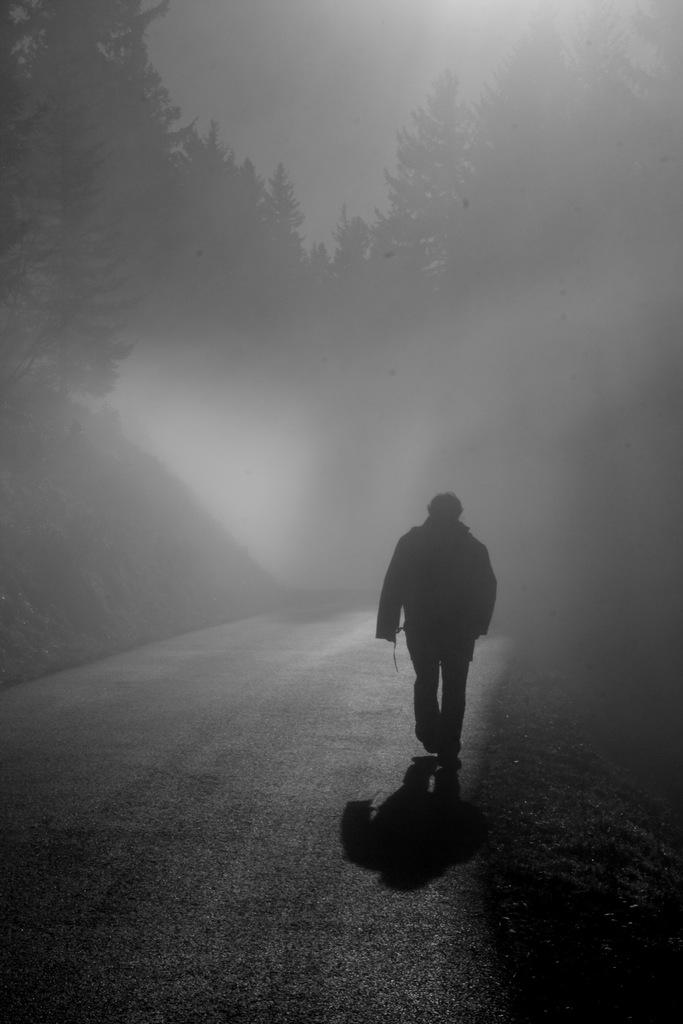What is the color scheme of the image? The image is black and white. What is the main subject of the image? There is a person walking on the road in the center of the image. What can be seen in the background of the image? The background of the image includes the sky, trees, and smoke. How many flowers can be seen on the road in the image? There are no flowers visible on the road in the image. Are there any ants crawling on the person walking in the image? There is no indication of ants in the image; the focus is on the person walking on the road. 